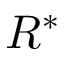<formula> <loc_0><loc_0><loc_500><loc_500>R ^ { * }</formula> 